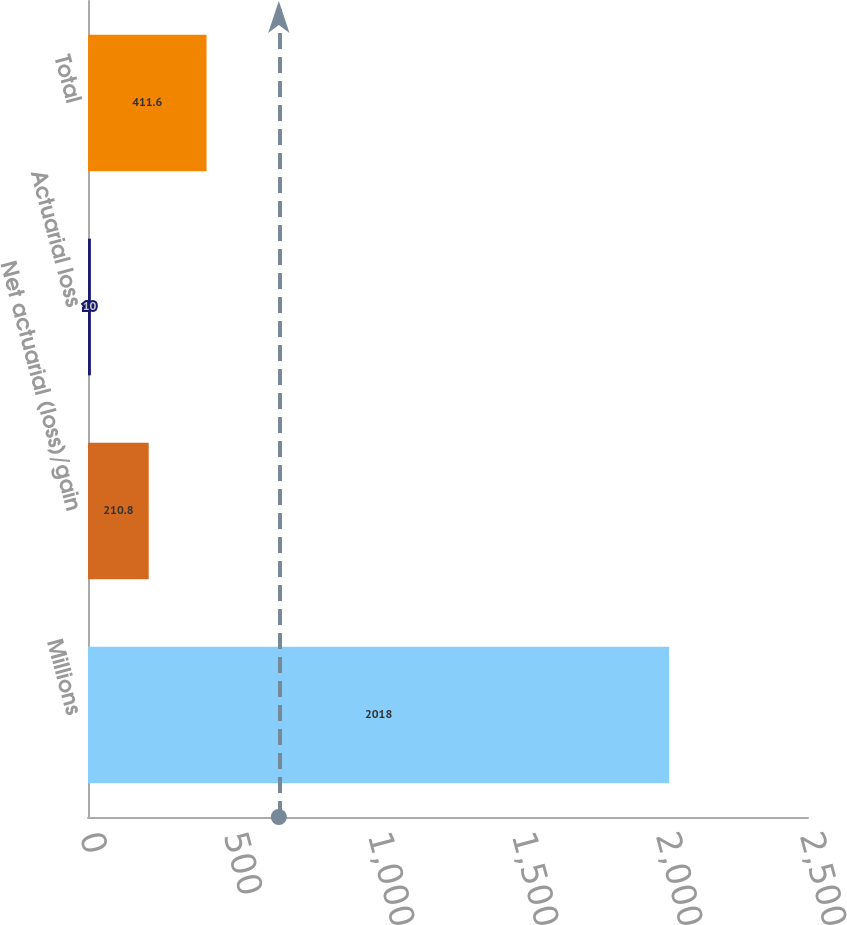Convert chart. <chart><loc_0><loc_0><loc_500><loc_500><bar_chart><fcel>Millions<fcel>Net actuarial (loss)/gain<fcel>Actuarial loss<fcel>Total<nl><fcel>2018<fcel>210.8<fcel>10<fcel>411.6<nl></chart> 